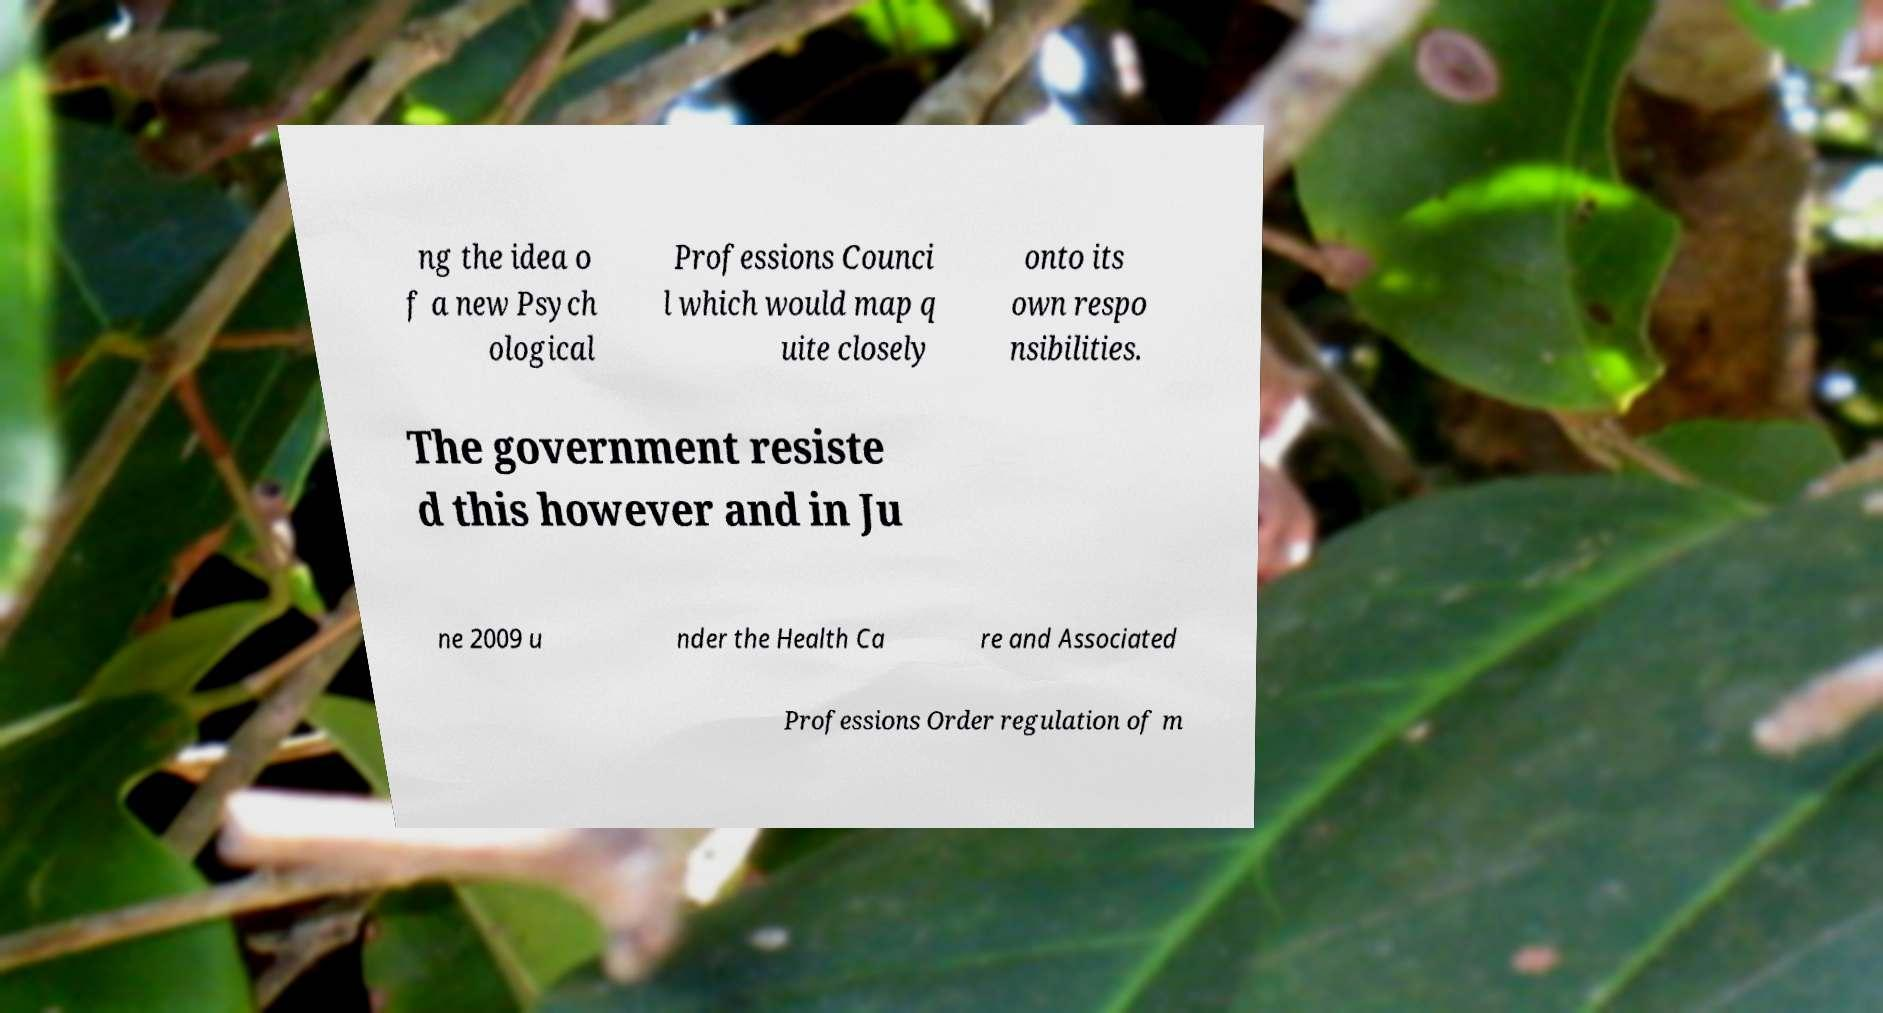There's text embedded in this image that I need extracted. Can you transcribe it verbatim? ng the idea o f a new Psych ological Professions Counci l which would map q uite closely onto its own respo nsibilities. The government resiste d this however and in Ju ne 2009 u nder the Health Ca re and Associated Professions Order regulation of m 